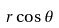<formula> <loc_0><loc_0><loc_500><loc_500>r \cos \theta</formula> 